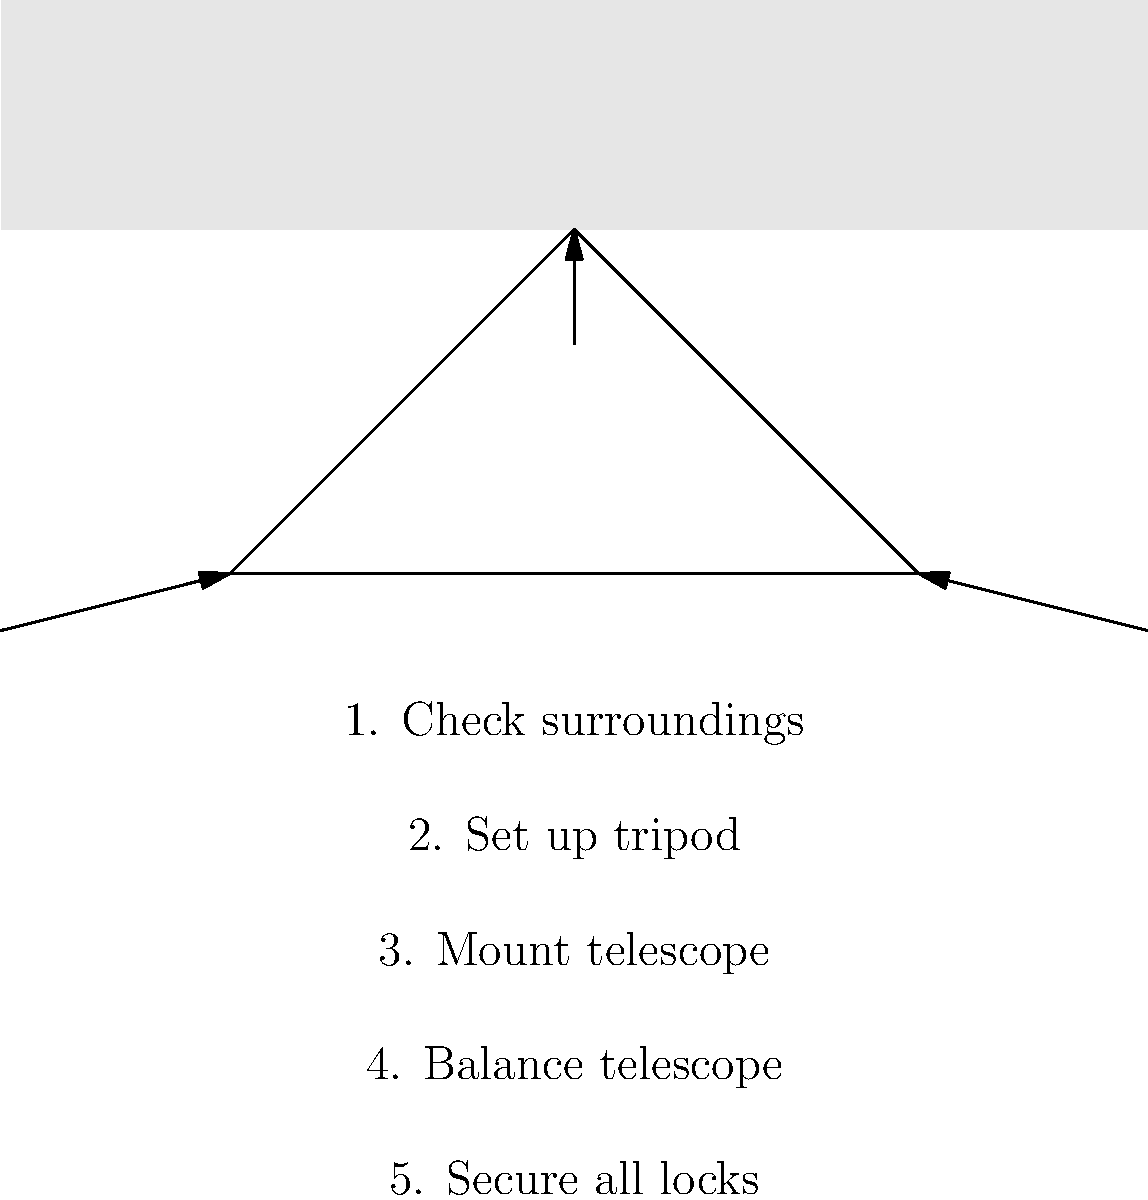What is the correct order of steps for safely setting up a telescope, as shown in the diagram? To safely set up a telescope, follow these steps:

1. Check surroundings: Ensure the area is clear of obstacles and hazards.
2. Set up tripod: Place the tripod on stable ground and extend its legs.
3. Mount telescope: Carefully attach the telescope to the tripod mount.
4. Balance telescope: Adjust the telescope's position for proper weight distribution.
5. Secure all locks: Tighten all knobs and locks to prevent unwanted movement.

This order ensures a safe and stable setup, minimizing the risk of equipment damage or personal injury. The diagram illustrates these steps in the correct sequence, emphasizing the importance of following proper procedures during field activities.
Answer: 1. Check surroundings, 2. Set up tripod, 3. Mount telescope, 4. Balance telescope, 5. Secure all locks 